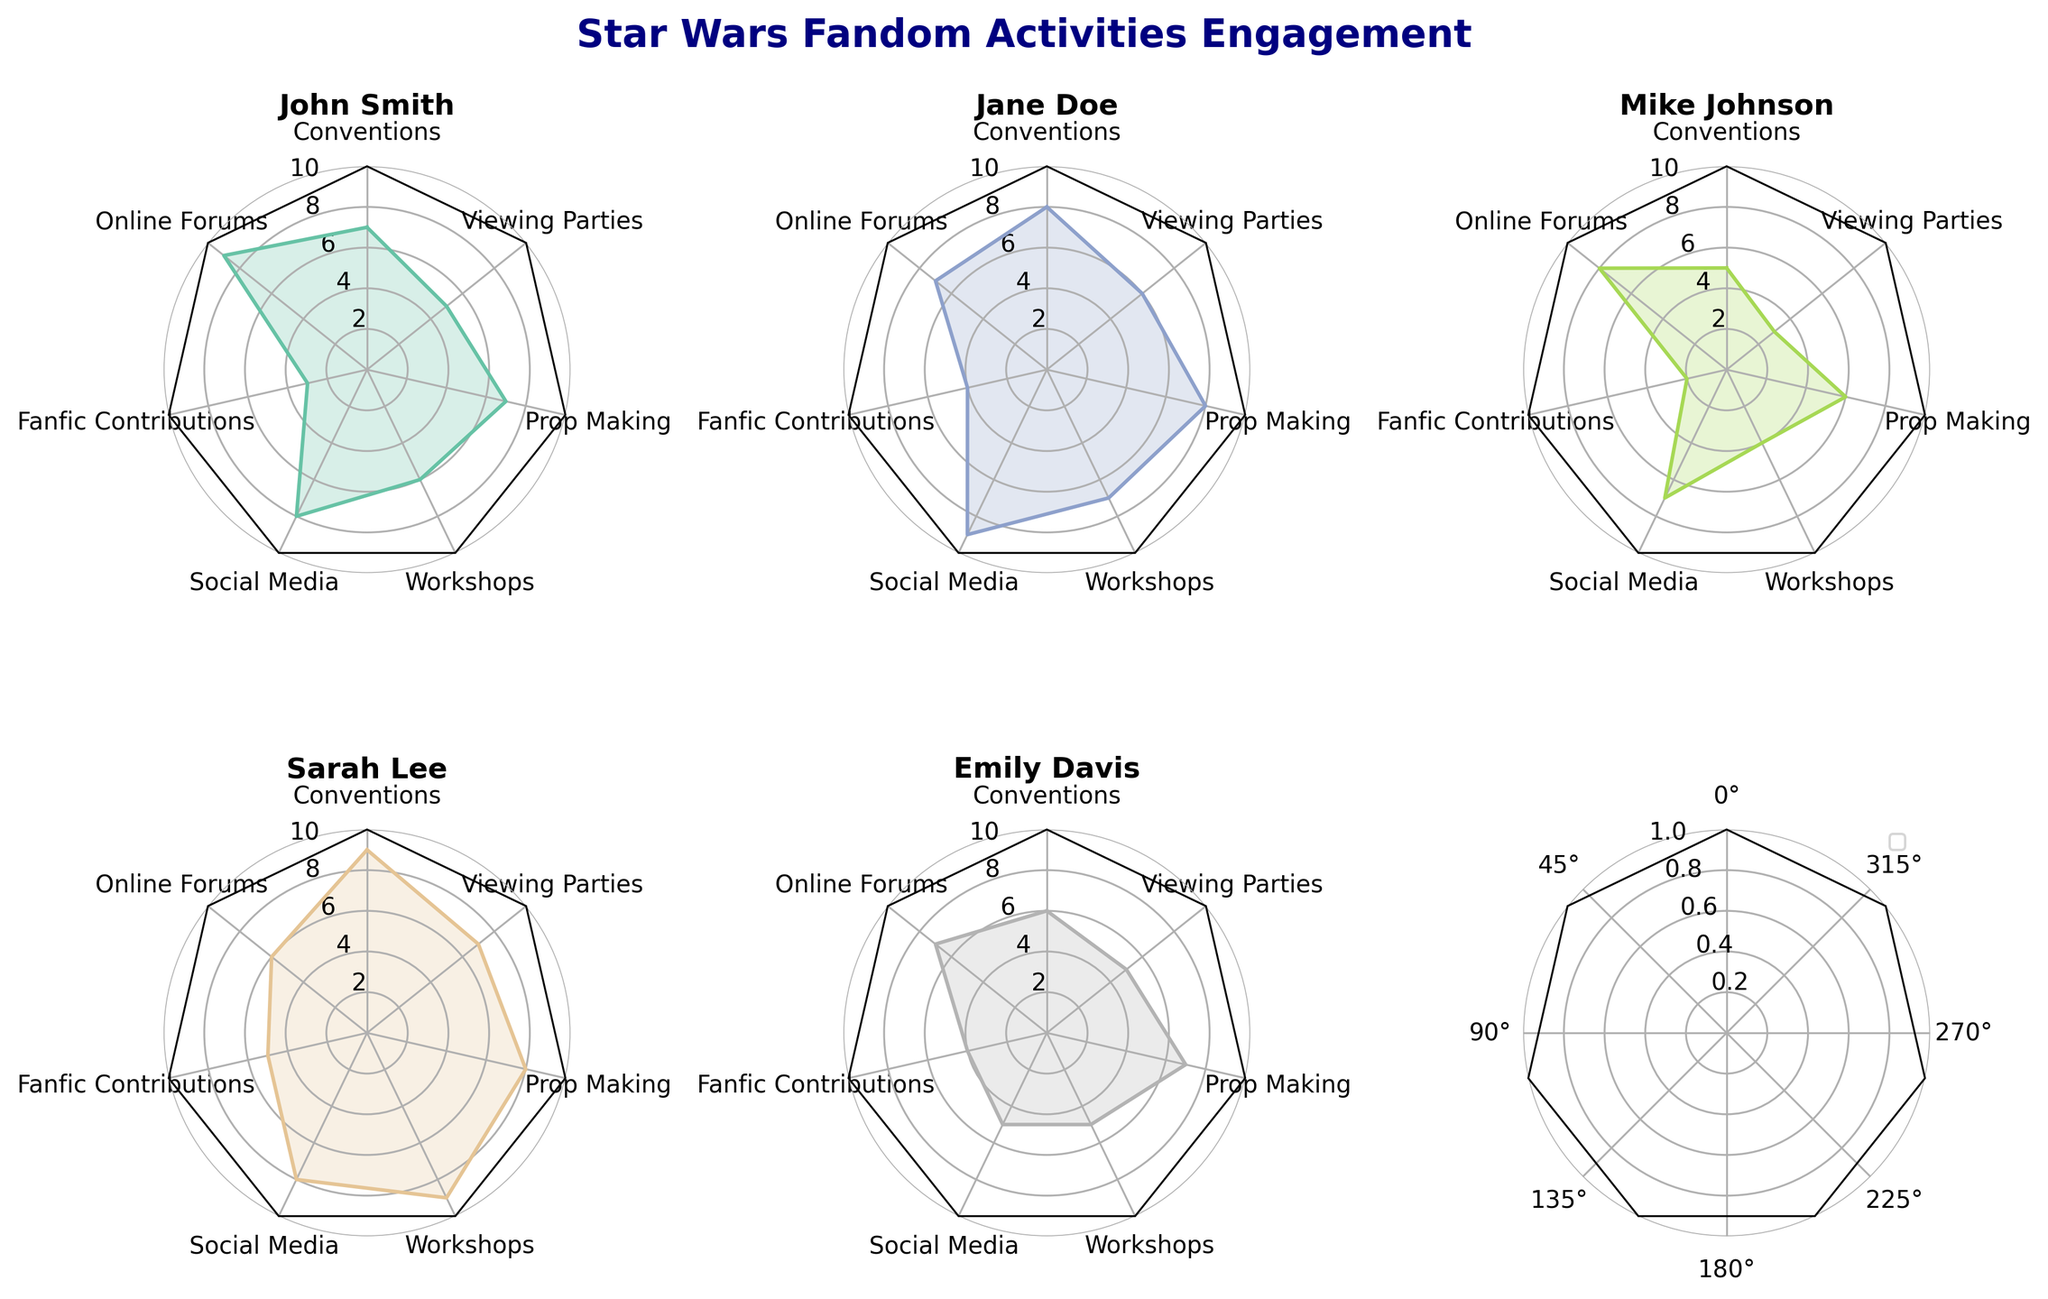What's the title of the figure? The title of the figure is typically found at the top of the figure. In this case, it is placed at the top-center part.
Answer: Star Wars Fandom Activities Engagement How many categories are there in each radar chart? Each radar chart has axes, and each axis represents a category. By counting the number of axes, we can determine the number of categories.
Answer: 7 Which individual has the highest engagement in "Social Media"? By visually comparing the engagement levels in the "Social Media" axis for all plots, the person with the graph that has the highest corresponding value holds this title. Sarah Lee has the highest score on the "Social Media" axis with a value of 8.
Answer: Sarah Lee What is the overall highest engagement level observed? To find the highest engagement level, look at the outermost points of each subplot. Each axis ranges from 0 to 10, and the highest value observed on any axis is 9.
Answer: 9 How does Jane Doe's engagement in "Workshops" compare to Mike Johnson's? Compare the values on the "Workshops" axis for both Jane Doe and Mike Johnson. Jane Doe has a value of 7 while Mike Johnson has a value of 4.
Answer: Jane Doe's engagement is higher What are the average values of "Viewing Parties" for all individuals? Average the values from each individual’s "Viewing Parties" axis. The values are 5, 6, 3, 7, and 5. Average: (5+6+3+7+5) / 5 = 26/5 = 5.2
Answer: 5.2 Whose radar chart has the largest value in the "Prop Making" category? Compare the values on the "Prop Making" axis across all individuals' radar charts. Both Jane Doe and Sarah Lee have the highest value of 8.
Answer: Jane Doe and Sarah Lee What is the median value of "Fanfic Contributions"? List and order the values for "Fanfic Contributions" (3, 4, 2, 5, 4). The median is the middle value.
Answer: 4 Which activity has the lowest engagement from Mike Johnson? Observe Mike Johnson's radar chart and find the smallest value among all activities. The smallest value in his chart is 2 for "Fanfic Contributions".
Answer: Fanfic Contributions Who has the most consistent level of engagement across all activities? Consistency can be gauged by the minimal difference between highest and lowest values in each individual’s plot. After examining all plots, Emily Davis has values ranging from 5 to 7.
Answer: Emily Davis 